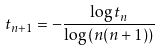<formula> <loc_0><loc_0><loc_500><loc_500>t _ { n + 1 } = - \frac { \log t _ { n } } { \log { ( n ( n + 1 ) ) } }</formula> 